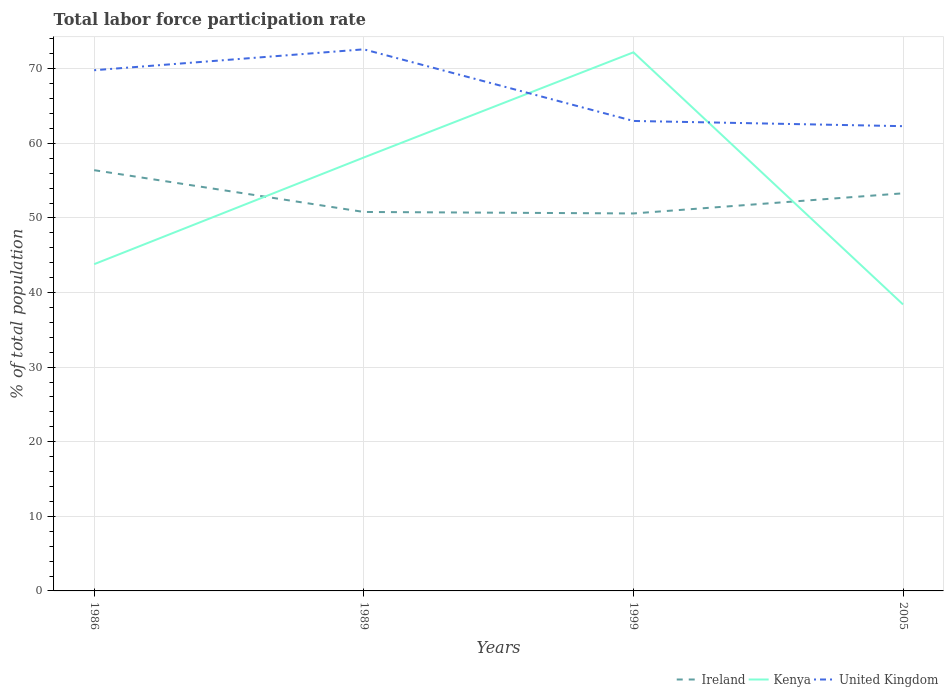Does the line corresponding to Ireland intersect with the line corresponding to United Kingdom?
Give a very brief answer. No. Across all years, what is the maximum total labor force participation rate in United Kingdom?
Offer a terse response. 62.3. What is the difference between the highest and the second highest total labor force participation rate in Kenya?
Give a very brief answer. 33.8. How many lines are there?
Keep it short and to the point. 3. Does the graph contain any zero values?
Provide a short and direct response. No. Does the graph contain grids?
Provide a succinct answer. Yes. What is the title of the graph?
Your response must be concise. Total labor force participation rate. What is the label or title of the Y-axis?
Your response must be concise. % of total population. What is the % of total population in Ireland in 1986?
Offer a terse response. 56.4. What is the % of total population in Kenya in 1986?
Make the answer very short. 43.8. What is the % of total population in United Kingdom in 1986?
Give a very brief answer. 69.8. What is the % of total population of Ireland in 1989?
Provide a succinct answer. 50.8. What is the % of total population of Kenya in 1989?
Provide a succinct answer. 58.1. What is the % of total population in United Kingdom in 1989?
Give a very brief answer. 72.6. What is the % of total population in Ireland in 1999?
Your response must be concise. 50.6. What is the % of total population in Kenya in 1999?
Provide a succinct answer. 72.2. What is the % of total population in United Kingdom in 1999?
Offer a terse response. 63. What is the % of total population in Ireland in 2005?
Your answer should be compact. 53.3. What is the % of total population in Kenya in 2005?
Make the answer very short. 38.4. What is the % of total population in United Kingdom in 2005?
Offer a terse response. 62.3. Across all years, what is the maximum % of total population of Ireland?
Give a very brief answer. 56.4. Across all years, what is the maximum % of total population of Kenya?
Your response must be concise. 72.2. Across all years, what is the maximum % of total population of United Kingdom?
Offer a terse response. 72.6. Across all years, what is the minimum % of total population of Ireland?
Your answer should be very brief. 50.6. Across all years, what is the minimum % of total population in Kenya?
Provide a short and direct response. 38.4. Across all years, what is the minimum % of total population in United Kingdom?
Make the answer very short. 62.3. What is the total % of total population of Ireland in the graph?
Your response must be concise. 211.1. What is the total % of total population in Kenya in the graph?
Offer a very short reply. 212.5. What is the total % of total population of United Kingdom in the graph?
Your answer should be compact. 267.7. What is the difference between the % of total population in Ireland in 1986 and that in 1989?
Ensure brevity in your answer.  5.6. What is the difference between the % of total population in Kenya in 1986 and that in 1989?
Provide a succinct answer. -14.3. What is the difference between the % of total population of Ireland in 1986 and that in 1999?
Give a very brief answer. 5.8. What is the difference between the % of total population of Kenya in 1986 and that in 1999?
Provide a short and direct response. -28.4. What is the difference between the % of total population in Ireland in 1986 and that in 2005?
Provide a short and direct response. 3.1. What is the difference between the % of total population of Kenya in 1986 and that in 2005?
Provide a short and direct response. 5.4. What is the difference between the % of total population of United Kingdom in 1986 and that in 2005?
Offer a very short reply. 7.5. What is the difference between the % of total population of Ireland in 1989 and that in 1999?
Provide a short and direct response. 0.2. What is the difference between the % of total population in Kenya in 1989 and that in 1999?
Keep it short and to the point. -14.1. What is the difference between the % of total population in United Kingdom in 1989 and that in 2005?
Ensure brevity in your answer.  10.3. What is the difference between the % of total population in Ireland in 1999 and that in 2005?
Offer a terse response. -2.7. What is the difference between the % of total population in Kenya in 1999 and that in 2005?
Keep it short and to the point. 33.8. What is the difference between the % of total population of Ireland in 1986 and the % of total population of Kenya in 1989?
Provide a succinct answer. -1.7. What is the difference between the % of total population in Ireland in 1986 and the % of total population in United Kingdom in 1989?
Offer a very short reply. -16.2. What is the difference between the % of total population of Kenya in 1986 and the % of total population of United Kingdom in 1989?
Offer a very short reply. -28.8. What is the difference between the % of total population of Ireland in 1986 and the % of total population of Kenya in 1999?
Your answer should be very brief. -15.8. What is the difference between the % of total population of Kenya in 1986 and the % of total population of United Kingdom in 1999?
Ensure brevity in your answer.  -19.2. What is the difference between the % of total population of Kenya in 1986 and the % of total population of United Kingdom in 2005?
Your response must be concise. -18.5. What is the difference between the % of total population of Ireland in 1989 and the % of total population of Kenya in 1999?
Your response must be concise. -21.4. What is the difference between the % of total population in Ireland in 1989 and the % of total population in United Kingdom in 1999?
Ensure brevity in your answer.  -12.2. What is the difference between the % of total population in Ireland in 1989 and the % of total population in Kenya in 2005?
Offer a terse response. 12.4. What is the difference between the % of total population of Kenya in 1989 and the % of total population of United Kingdom in 2005?
Keep it short and to the point. -4.2. What is the difference between the % of total population of Ireland in 1999 and the % of total population of Kenya in 2005?
Make the answer very short. 12.2. What is the difference between the % of total population of Kenya in 1999 and the % of total population of United Kingdom in 2005?
Your answer should be very brief. 9.9. What is the average % of total population in Ireland per year?
Ensure brevity in your answer.  52.77. What is the average % of total population in Kenya per year?
Your answer should be very brief. 53.12. What is the average % of total population in United Kingdom per year?
Your answer should be very brief. 66.92. In the year 1986, what is the difference between the % of total population in Ireland and % of total population in Kenya?
Give a very brief answer. 12.6. In the year 1986, what is the difference between the % of total population of Ireland and % of total population of United Kingdom?
Your answer should be compact. -13.4. In the year 1989, what is the difference between the % of total population in Ireland and % of total population in United Kingdom?
Keep it short and to the point. -21.8. In the year 1989, what is the difference between the % of total population in Kenya and % of total population in United Kingdom?
Your response must be concise. -14.5. In the year 1999, what is the difference between the % of total population in Ireland and % of total population in Kenya?
Your answer should be compact. -21.6. In the year 1999, what is the difference between the % of total population of Ireland and % of total population of United Kingdom?
Keep it short and to the point. -12.4. In the year 1999, what is the difference between the % of total population of Kenya and % of total population of United Kingdom?
Your answer should be compact. 9.2. In the year 2005, what is the difference between the % of total population in Ireland and % of total population in Kenya?
Your answer should be compact. 14.9. In the year 2005, what is the difference between the % of total population of Kenya and % of total population of United Kingdom?
Your response must be concise. -23.9. What is the ratio of the % of total population of Ireland in 1986 to that in 1989?
Your answer should be very brief. 1.11. What is the ratio of the % of total population of Kenya in 1986 to that in 1989?
Your answer should be very brief. 0.75. What is the ratio of the % of total population of United Kingdom in 1986 to that in 1989?
Provide a succinct answer. 0.96. What is the ratio of the % of total population in Ireland in 1986 to that in 1999?
Provide a short and direct response. 1.11. What is the ratio of the % of total population of Kenya in 1986 to that in 1999?
Your response must be concise. 0.61. What is the ratio of the % of total population in United Kingdom in 1986 to that in 1999?
Provide a short and direct response. 1.11. What is the ratio of the % of total population of Ireland in 1986 to that in 2005?
Offer a very short reply. 1.06. What is the ratio of the % of total population of Kenya in 1986 to that in 2005?
Make the answer very short. 1.14. What is the ratio of the % of total population of United Kingdom in 1986 to that in 2005?
Your answer should be compact. 1.12. What is the ratio of the % of total population of Kenya in 1989 to that in 1999?
Ensure brevity in your answer.  0.8. What is the ratio of the % of total population of United Kingdom in 1989 to that in 1999?
Make the answer very short. 1.15. What is the ratio of the % of total population in Ireland in 1989 to that in 2005?
Your answer should be compact. 0.95. What is the ratio of the % of total population in Kenya in 1989 to that in 2005?
Offer a very short reply. 1.51. What is the ratio of the % of total population in United Kingdom in 1989 to that in 2005?
Make the answer very short. 1.17. What is the ratio of the % of total population in Ireland in 1999 to that in 2005?
Give a very brief answer. 0.95. What is the ratio of the % of total population in Kenya in 1999 to that in 2005?
Ensure brevity in your answer.  1.88. What is the ratio of the % of total population in United Kingdom in 1999 to that in 2005?
Keep it short and to the point. 1.01. What is the difference between the highest and the second highest % of total population in Ireland?
Provide a succinct answer. 3.1. What is the difference between the highest and the second highest % of total population of United Kingdom?
Your answer should be compact. 2.8. What is the difference between the highest and the lowest % of total population of Kenya?
Your answer should be very brief. 33.8. 